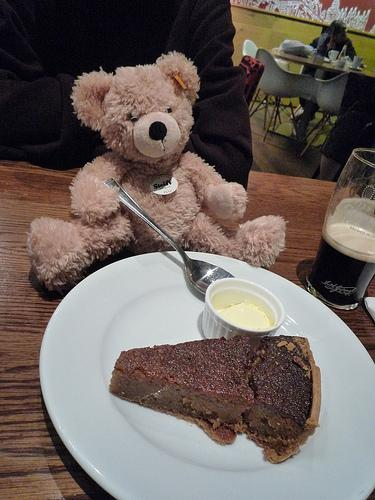What is the color of the teddy bear and what is it holding? The teddy bear is tan in color and it is holding a spoon in its paw. Describe the person in the image and their actions. There is a person sitting at a table wearing a dark colored shirt, possibly engaging in a conversation or enjoying a meal. Explain the position of the tables and the person in relation to one another. The person sits at a table, with another table behind the front table in the background. List the main items found on the table. Items on the table include a pecan pie, a piece of pie, a spoon, a teddy bear holding a spoon, a dish of butter, and a glass of brown frothy drink. Identify the dessert on the table and describe how it is served. There is a pecan pie on the table, served on a white plate with a piece of pie and a spoon nearby. Analyze the surface where the pie is placed and describe its characteristics. The pie is placed on a brown table with a striped pattern. What type of furniture can be seen in the background of the image? Three white chairs can be seen in the background. What kind of drink is in the glass and how full is it? There is a brown frothy drink in the glass, likely a half-empty beer. Describe the scene involving the teddy bear, including the objects around it and its position. The teddy bear is on the table, it is tan in color and holding a spoon in its paw. It is near a pecan pie, a piece of pie, and a dish of butter. Mention the objects on the white plate along with their relative positions. A piece of pie and a spoon are on the white plate, with the piece of pie next to the dish of butter. The person sitting at the table is wearing a bright-colored shirt. The person is actually wearing a dark-colored shirt, not a bright-colored one. Find the green teddy bear sitting on the chair. There's no green teddy bear in the image, and the teddy bear is on a table, not sitting on a chair. There is a child sitting on one of the white chairs. There is no child in the image, only a person at the table and people in the background. Observe a plate of spaghetti on the brown table. There's no spaghetti in the image, only a plate with a piece of pie. Notice the blue striped pattern on the table. The table is actually brown with a striped pattern, not blue. Can you find a cup of coffee on the table next to the teddy bear? There's no cup of coffee in the image, only a half-empty glass of beer. Is the teddy bear holding a fork instead of a spoon? The teddy bear is actually holding a spoon, not a fork. Can you see a full glass of light-colored beer on the table? The glass of beer in the picture is half-empty and dark in color. Observe two large pink chairs in the background. There are three white chairs in the background, not two pink ones. The teddy bear is wearing a colorful hat on its head. There's no hat on the teddy bear in the image. 